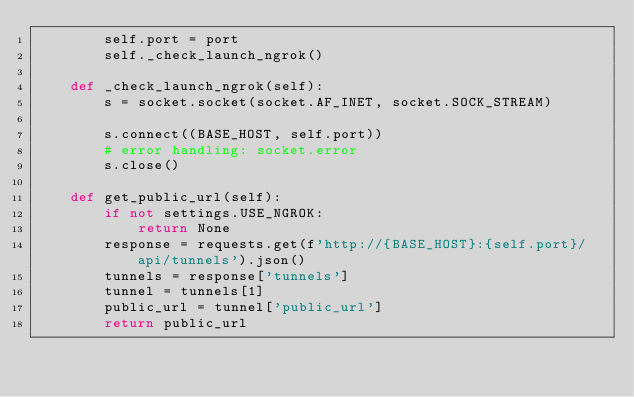Convert code to text. <code><loc_0><loc_0><loc_500><loc_500><_Python_>        self.port = port
        self._check_launch_ngrok()

    def _check_launch_ngrok(self):
        s = socket.socket(socket.AF_INET, socket.SOCK_STREAM)

        s.connect((BASE_HOST, self.port))
        # error handling: socket.error
        s.close()

    def get_public_url(self):
        if not settings.USE_NGROK:
            return None
        response = requests.get(f'http://{BASE_HOST}:{self.port}/api/tunnels').json()
        tunnels = response['tunnels']
        tunnel = tunnels[1]
        public_url = tunnel['public_url']
        return public_url
</code> 